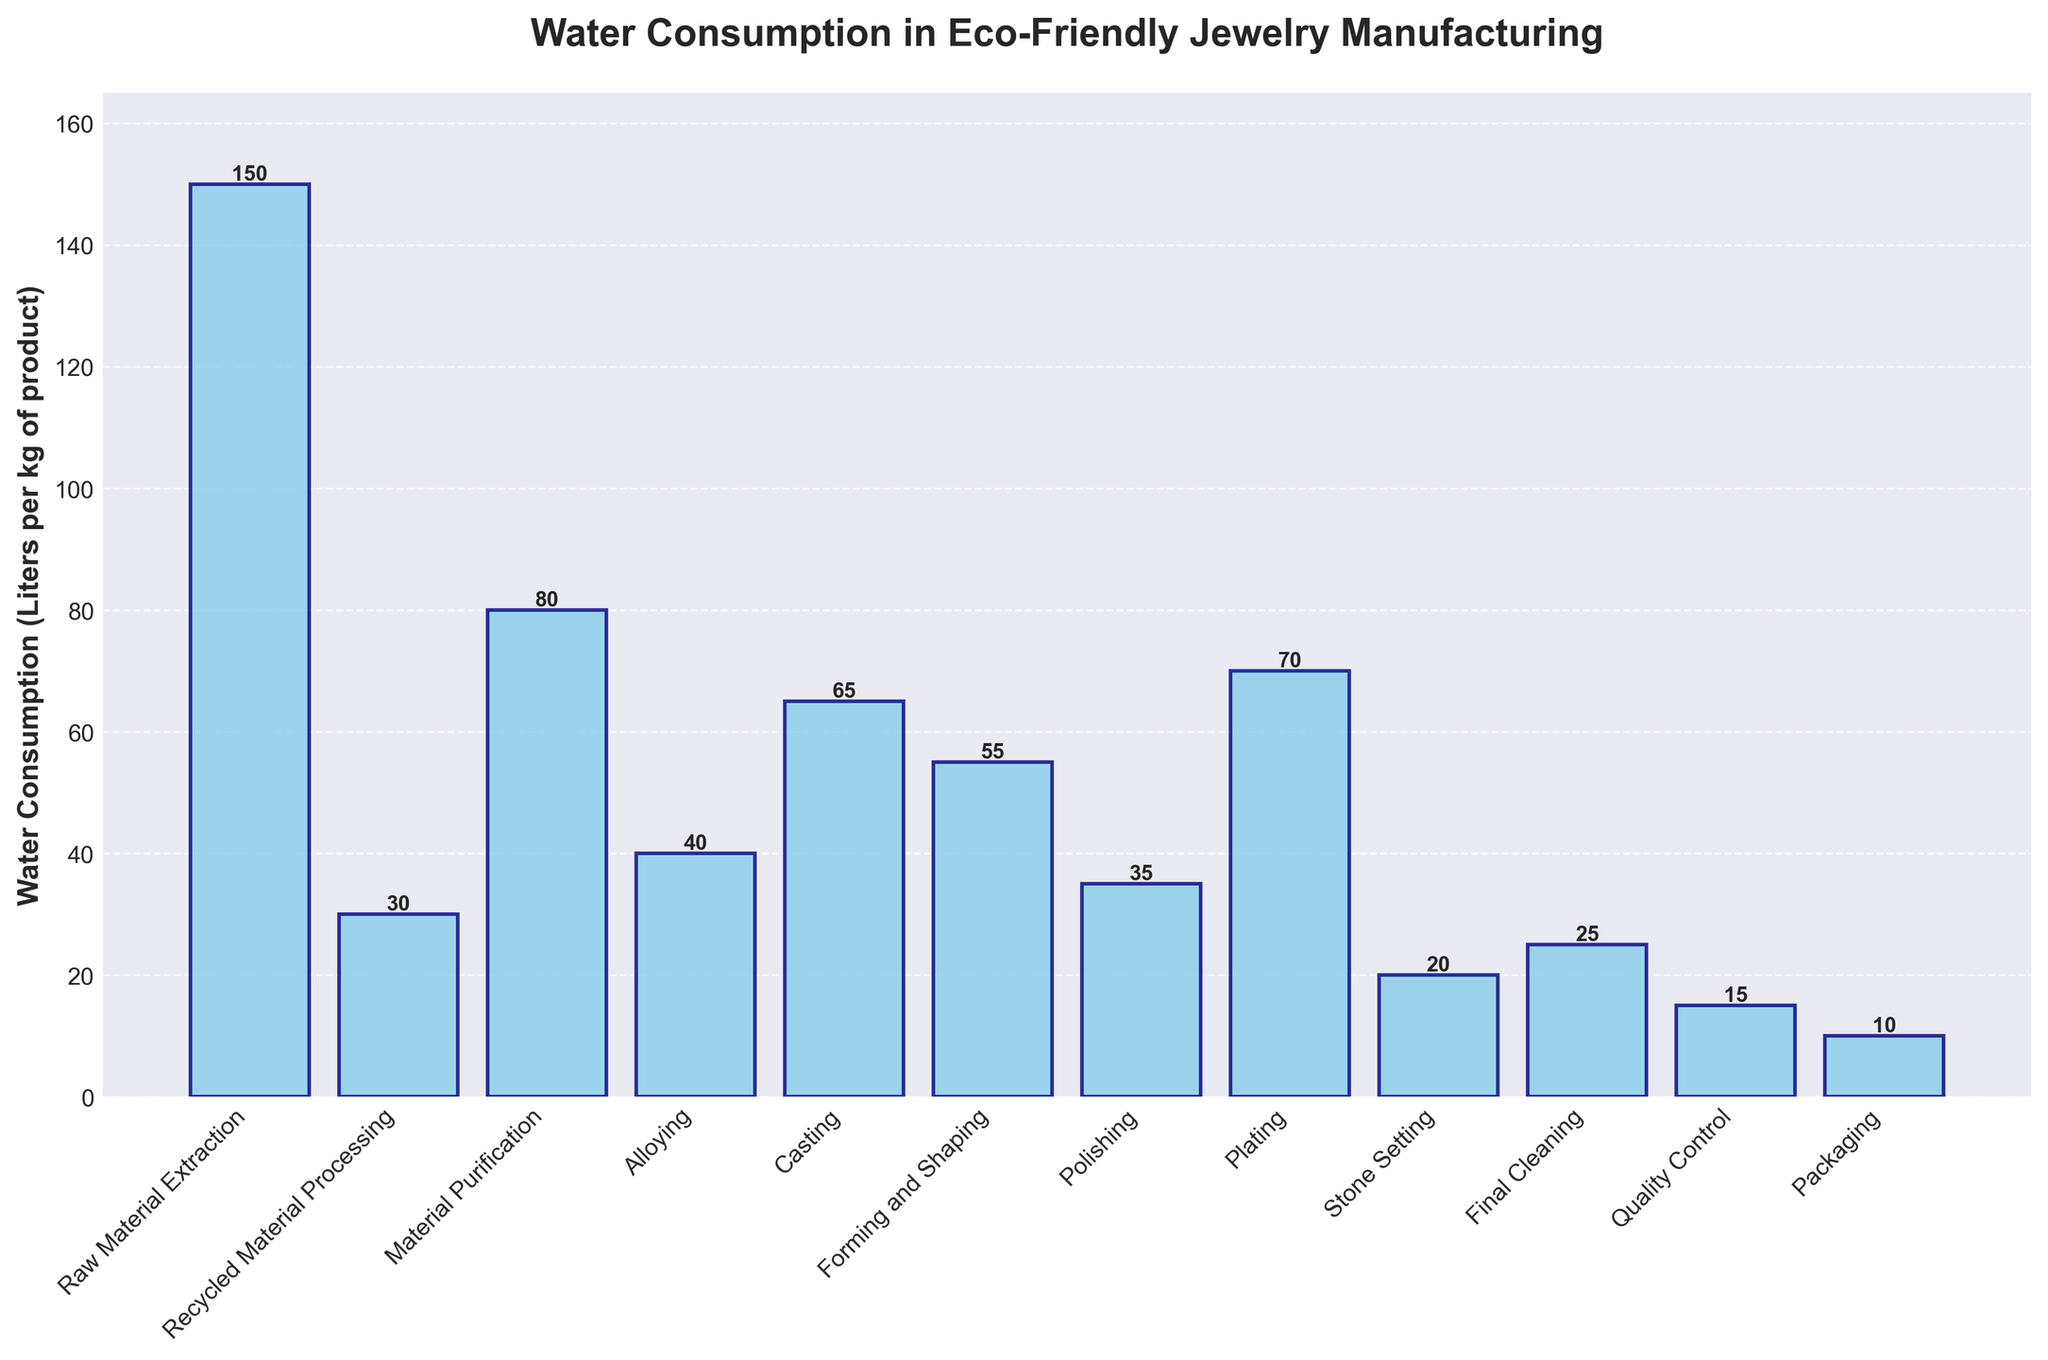Which stage has the highest water consumption? By inspecting the height of the bars, the highest water consumption corresponds to the "Raw Material Extraction" stage with a height of 150 liters per kg of product
Answer: Raw Material Extraction Which stage has the lowest water consumption? By inspecting the height of the bars, the lowest water consumption corresponds to the "Packaging" stage with a height of 10 liters per kg of product
Answer: Packaging What is the sum of water consumption for Polishing and Final Cleaning? To find the sum, add the values for "Polishing" (35 liters) and "Final Cleaning" (25 liters): 35 + 25 = 60
Answer: 60 Does the Alloying stage consume more water than the Casting stage? Compare the heights of the bars for "Alloying" (40 liters) and "Casting" (65 liters). Since 40 is less than 65, Alloying consumes less water
Answer: No What is the average water consumption of the first three stages? Sum the water consumption of "Raw Material Extraction" (150 liters), "Recycled Material Processing" (30 liters), and "Material Purification" (80 liters), then divide by 3: (150 + 30 + 80)/3 = 86.67
Answer: 86.67 Which stage consumes more water, Stone Setting or Quality Control? Compare the heights of the bars for "Stone Setting" (20 liters) and "Quality Control" (15 liters). Since 20 is greater than 15, Stone Setting consumes more water
Answer: Stone Setting What is the difference in water consumption between Casting and Forming and Shaping stages? Subtract the value of "Forming and Shaping" (55 liters) from the value of "Casting" (65 liters): 65 - 55 = 10
Answer: 10 Which stages consume less than 30 liters of water per kg of product? Inspect the heights of the bars and list the stages with values less than 30: "Stone Setting" (20 liters), "Final Cleaning" (25 liters), "Quality Control" (15 liters), "Packaging" (10 liters)
Answer: Stone Setting, Final Cleaning, Quality Control, Packaging What is the total water consumption for the stages involving finishing processes (Polishing, Plating, Stone Setting, Final Cleaning, Quality Control, and Packaging)? Sum the values for "Polishing" (35 liters), "Plating" (70 liters), "Stone Setting" (20 liters), "Final Cleaning" (25 liters), "Quality Control" (15 liters), and "Packaging" (10 liters): 35 + 70 + 20 + 25 + 15 + 10 = 175
Answer: 175 